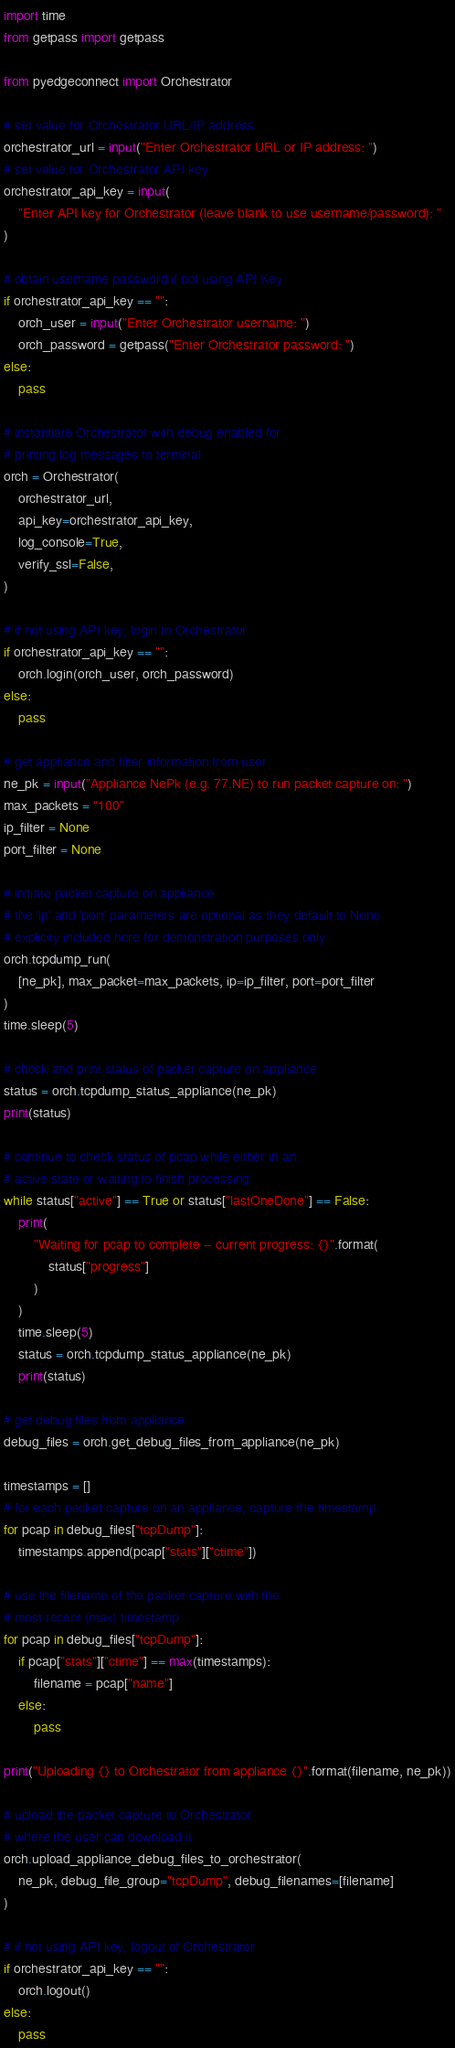<code> <loc_0><loc_0><loc_500><loc_500><_Python_>import time
from getpass import getpass

from pyedgeconnect import Orchestrator

# set value for Orchestrator URL/IP address
orchestrator_url = input("Enter Orchestrator URL or IP address: ")
# set value for Orchestrator API key
orchestrator_api_key = input(
    "Enter API key for Orchestrator (leave blank to use username/password): "
)

# obtain username password if not using API Key
if orchestrator_api_key == "":
    orch_user = input("Enter Orchestrator username: ")
    orch_password = getpass("Enter Orchestrator password: ")
else:
    pass

# instantiate Orchestrator with debug enabled for
# printing log messages to terminal
orch = Orchestrator(
    orchestrator_url,
    api_key=orchestrator_api_key,
    log_console=True,
    verify_ssl=False,
)

# if not using API key, login to Orchestrator
if orchestrator_api_key == "":
    orch.login(orch_user, orch_password)
else:
    pass

# get appliance and filter information from user
ne_pk = input("Appliance NePk (e.g. 77.NE) to run packet capture on: ")
max_packets = "100"
ip_filter = None
port_filter = None

# initiate packet capture on appliance
# the 'ip' and 'port' parameters are optional as they default to None
# explicity included here for demonstration purposes only
orch.tcpdump_run(
    [ne_pk], max_packet=max_packets, ip=ip_filter, port=port_filter
)
time.sleep(5)

# check and print status of packet capture on appliance
status = orch.tcpdump_status_appliance(ne_pk)
print(status)

# continue to check status of pcap while either in an
# active state or waiting to finish processing
while status["active"] == True or status["lastOneDone"] == False:
    print(
        "Waiting for pcap to complete -- current progress: {}".format(
            status["progress"]
        )
    )
    time.sleep(5)
    status = orch.tcpdump_status_appliance(ne_pk)
    print(status)

# get debug files from appliance
debug_files = orch.get_debug_files_from_appliance(ne_pk)

timestamps = []
# for each packet capture on an appliance, capture the timestamp
for pcap in debug_files["tcpDump"]:
    timestamps.append(pcap["stats"]["ctime"])

# use the filename of the packet capture with the
# most recent (max) timestamp
for pcap in debug_files["tcpDump"]:
    if pcap["stats"]["ctime"] == max(timestamps):
        filename = pcap["name"]
    else:
        pass

print("Uploading {} to Orchestrator from appliance {}".format(filename, ne_pk))

# upload the packet capture to Orchestrator
# where the user can download it
orch.upload_appliance_debug_files_to_orchestrator(
    ne_pk, debug_file_group="tcpDump", debug_filenames=[filename]
)

# if not using API key, logout of Orchestrator
if orchestrator_api_key == "":
    orch.logout()
else:
    pass
</code> 